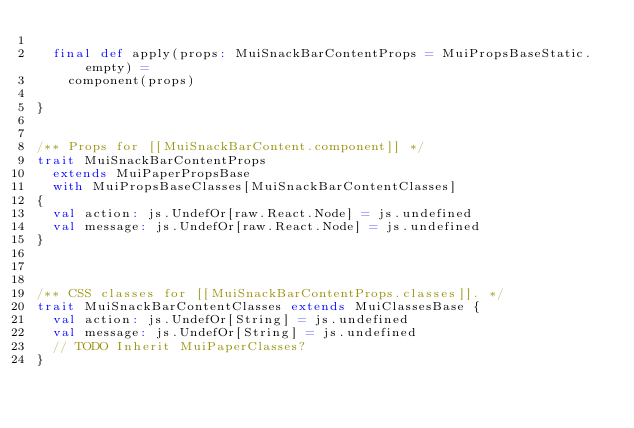Convert code to text. <code><loc_0><loc_0><loc_500><loc_500><_Scala_>
  final def apply(props: MuiSnackBarContentProps = MuiPropsBaseStatic.empty) =
    component(props)

}


/** Props for [[MuiSnackBarContent.component]] */
trait MuiSnackBarContentProps
  extends MuiPaperPropsBase
  with MuiPropsBaseClasses[MuiSnackBarContentClasses]
{
  val action: js.UndefOr[raw.React.Node] = js.undefined
  val message: js.UndefOr[raw.React.Node] = js.undefined
}



/** CSS classes for [[MuiSnackBarContentProps.classes]]. */
trait MuiSnackBarContentClasses extends MuiClassesBase {
  val action: js.UndefOr[String] = js.undefined
  val message: js.UndefOr[String] = js.undefined
  // TODO Inherit MuiPaperClasses?
}

</code> 